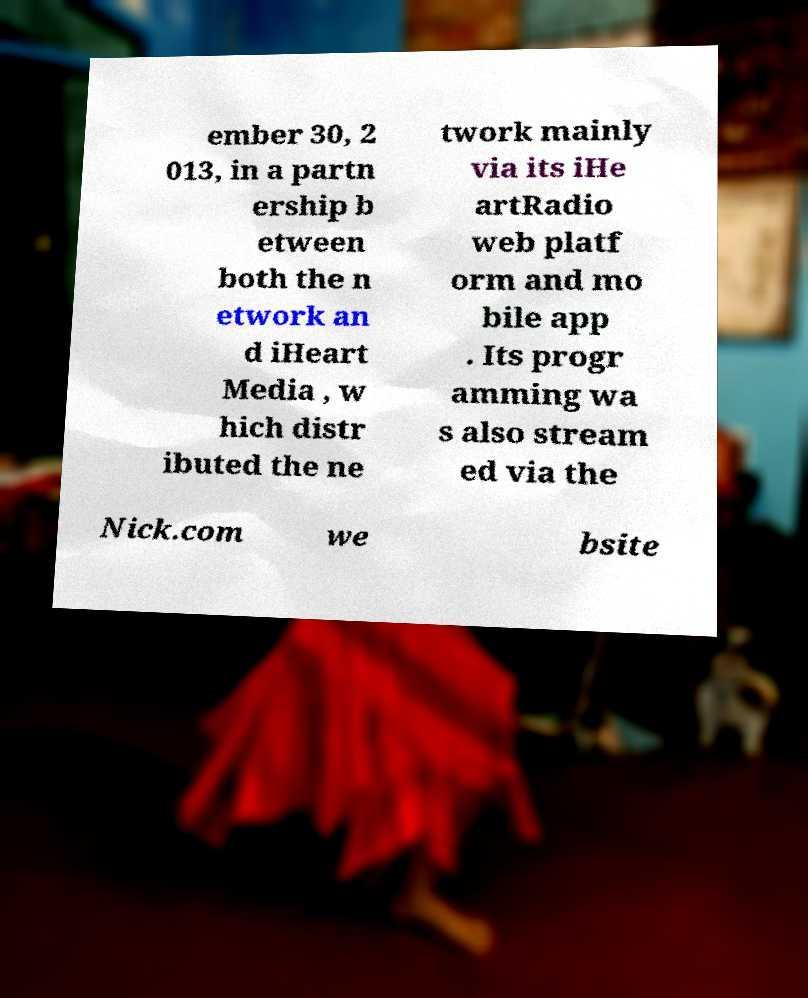Please read and relay the text visible in this image. What does it say? ember 30, 2 013, in a partn ership b etween both the n etwork an d iHeart Media , w hich distr ibuted the ne twork mainly via its iHe artRadio web platf orm and mo bile app . Its progr amming wa s also stream ed via the Nick.com we bsite 